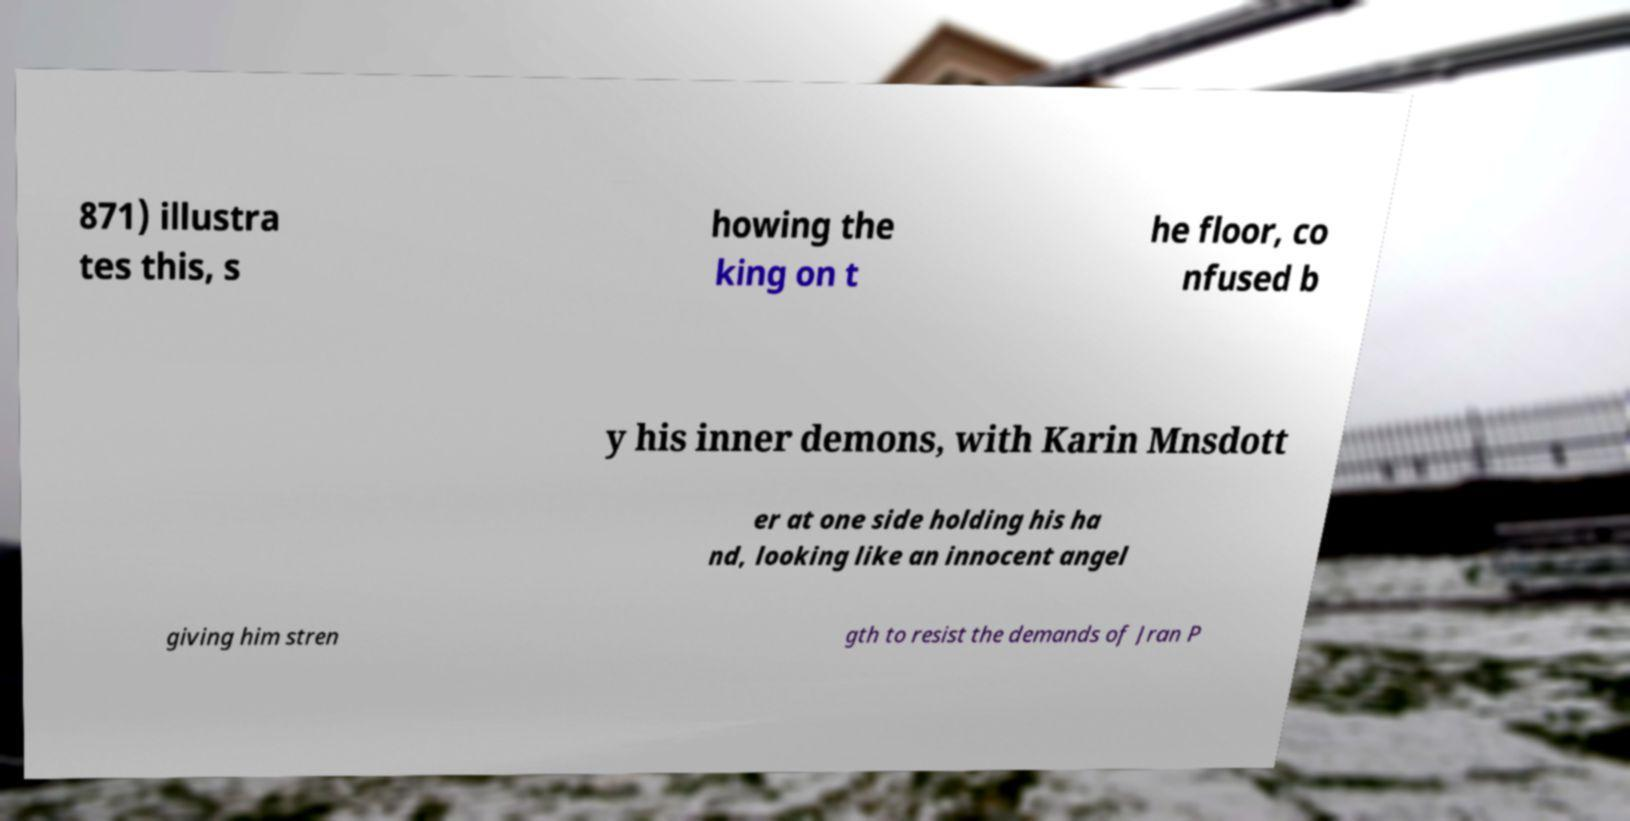For documentation purposes, I need the text within this image transcribed. Could you provide that? 871) illustra tes this, s howing the king on t he floor, co nfused b y his inner demons, with Karin Mnsdott er at one side holding his ha nd, looking like an innocent angel giving him stren gth to resist the demands of Jran P 